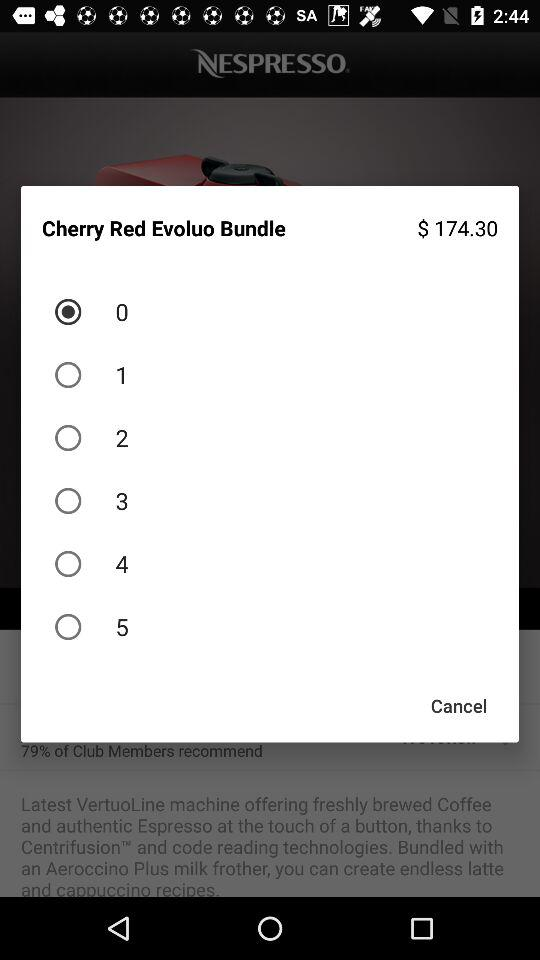What is the price of the "Cherry Red Evoluo Bundle"? The price is $174.30. 